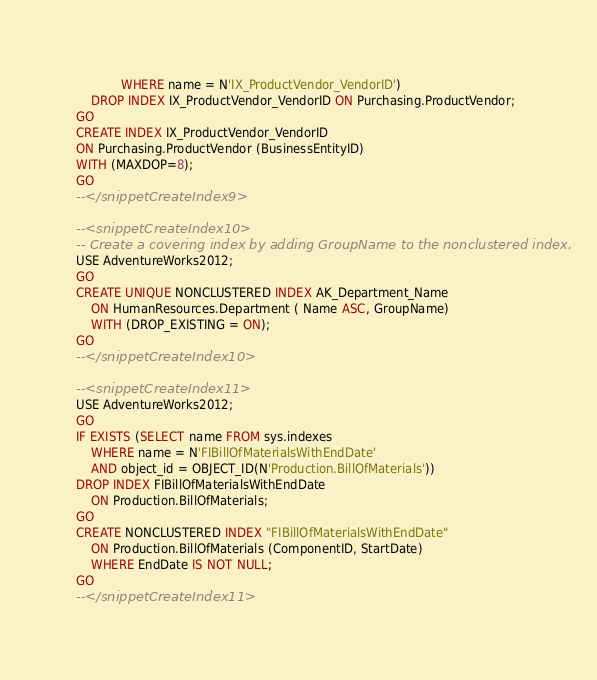<code> <loc_0><loc_0><loc_500><loc_500><_SQL_>            WHERE name = N'IX_ProductVendor_VendorID')
    DROP INDEX IX_ProductVendor_VendorID ON Purchasing.ProductVendor;
GO
CREATE INDEX IX_ProductVendor_VendorID 
ON Purchasing.ProductVendor (BusinessEntityID)
WITH (MAXDOP=8);
GO
--</snippetCreateIndex9>

--<snippetCreateIndex10>
-- Create a covering index by adding GroupName to the nonclustered index.
USE AdventureWorks2012;
GO
CREATE UNIQUE NONCLUSTERED INDEX AK_Department_Name
    ON HumanResources.Department ( Name ASC, GroupName)
    WITH (DROP_EXISTING = ON);
GO
--</snippetCreateIndex10>

--<snippetCreateIndex11>
USE AdventureWorks2012;
GO
IF EXISTS (SELECT name FROM sys.indexes
    WHERE name = N'FIBillOfMaterialsWithEndDate' 
    AND object_id = OBJECT_ID(N'Production.BillOfMaterials'))
DROP INDEX FIBillOfMaterialsWithEndDate
    ON Production.BillOfMaterials;
GO
CREATE NONCLUSTERED INDEX "FIBillOfMaterialsWithEndDate"
    ON Production.BillOfMaterials (ComponentID, StartDate)
    WHERE EndDate IS NOT NULL;
GO
--</snippetCreateIndex11>



</code> 